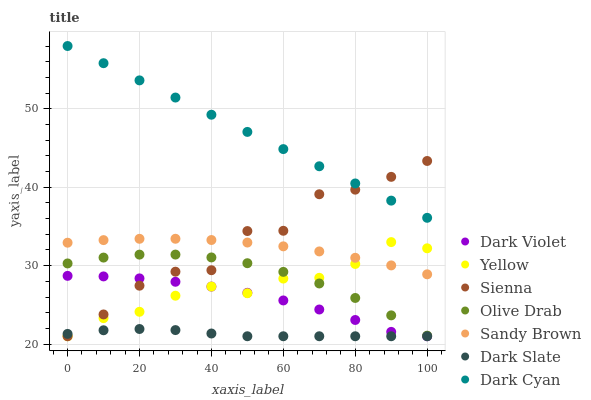Does Dark Slate have the minimum area under the curve?
Answer yes or no. Yes. Does Dark Cyan have the maximum area under the curve?
Answer yes or no. Yes. Does Sienna have the minimum area under the curve?
Answer yes or no. No. Does Sienna have the maximum area under the curve?
Answer yes or no. No. Is Dark Cyan the smoothest?
Answer yes or no. Yes. Is Sienna the roughest?
Answer yes or no. Yes. Is Dark Slate the smoothest?
Answer yes or no. No. Is Dark Slate the roughest?
Answer yes or no. No. Does Yellow have the lowest value?
Answer yes or no. Yes. Does Dark Cyan have the lowest value?
Answer yes or no. No. Does Dark Cyan have the highest value?
Answer yes or no. Yes. Does Sienna have the highest value?
Answer yes or no. No. Is Yellow less than Dark Cyan?
Answer yes or no. Yes. Is Olive Drab greater than Dark Slate?
Answer yes or no. Yes. Does Yellow intersect Sienna?
Answer yes or no. Yes. Is Yellow less than Sienna?
Answer yes or no. No. Is Yellow greater than Sienna?
Answer yes or no. No. Does Yellow intersect Dark Cyan?
Answer yes or no. No. 